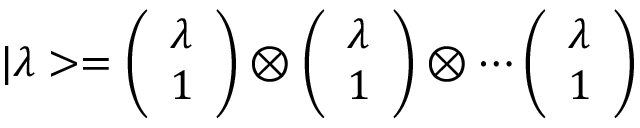Convert formula to latex. <formula><loc_0><loc_0><loc_500><loc_500>| \lambda > = \left ( \begin{array} { c } { \lambda } \\ { 1 } \end{array} \right ) \otimes \left ( \begin{array} { c } { \lambda } \\ { 1 } \end{array} \right ) \otimes \cdots \left ( \begin{array} { c } { \lambda } \\ { 1 } \end{array} \right )</formula> 